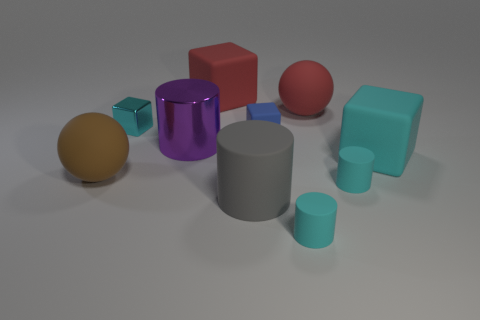Subtract 1 cubes. How many cubes are left? 3 Subtract all cylinders. How many objects are left? 6 Subtract all brown rubber balls. Subtract all purple metallic things. How many objects are left? 8 Add 3 large cylinders. How many large cylinders are left? 5 Add 4 spheres. How many spheres exist? 6 Subtract 0 green balls. How many objects are left? 10 